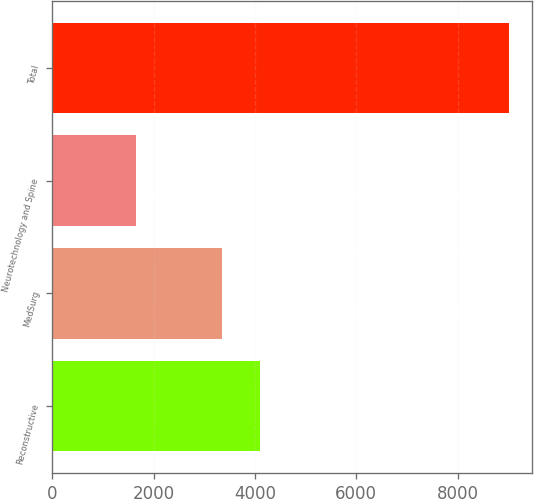<chart> <loc_0><loc_0><loc_500><loc_500><bar_chart><fcel>Reconstructive<fcel>MedSurg<fcel>Neurotechnology and Spine<fcel>Total<nl><fcel>4095.3<fcel>3359<fcel>1658<fcel>9021<nl></chart> 